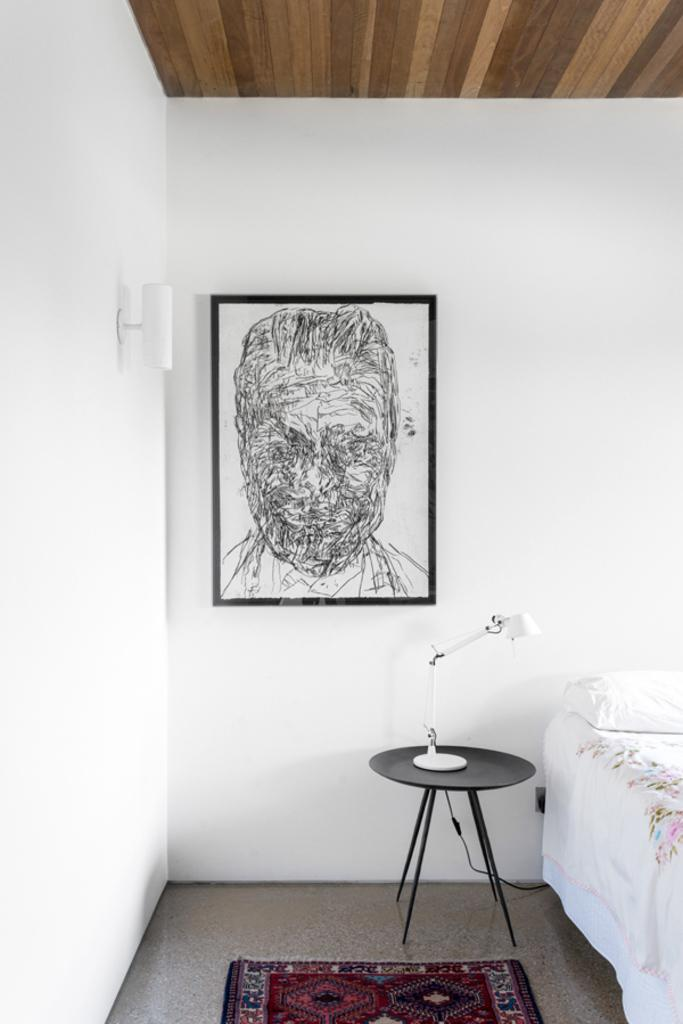What is hanging on the wall in the image? There is a photo frame on the wall. What piece of furniture is present in the image? There is a bed in the image. What is placed on the bed? There is a pillow on the bed. What type of lighting is present on a table in the image? There is a table lamp on a table. What type of floor covering is visible in the image? There is a carpet on the floor. Where is the light source attached in the image? There is a light attached to the wall. How many girls are visible in the image? There are no girls present in the image. What type of glass object can be seen on the bed? There is no glass object present on the bed; only a pillow is visible. 